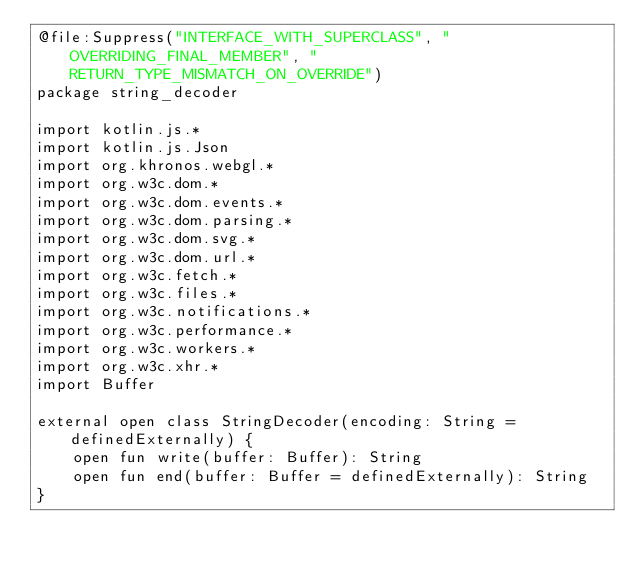<code> <loc_0><loc_0><loc_500><loc_500><_Kotlin_>@file:Suppress("INTERFACE_WITH_SUPERCLASS", "OVERRIDING_FINAL_MEMBER", "RETURN_TYPE_MISMATCH_ON_OVERRIDE")
package string_decoder

import kotlin.js.*
import kotlin.js.Json
import org.khronos.webgl.*
import org.w3c.dom.*
import org.w3c.dom.events.*
import org.w3c.dom.parsing.*
import org.w3c.dom.svg.*
import org.w3c.dom.url.*
import org.w3c.fetch.*
import org.w3c.files.*
import org.w3c.notifications.*
import org.w3c.performance.*
import org.w3c.workers.*
import org.w3c.xhr.*
import Buffer

external open class StringDecoder(encoding: String = definedExternally) {
    open fun write(buffer: Buffer): String
    open fun end(buffer: Buffer = definedExternally): String
}</code> 